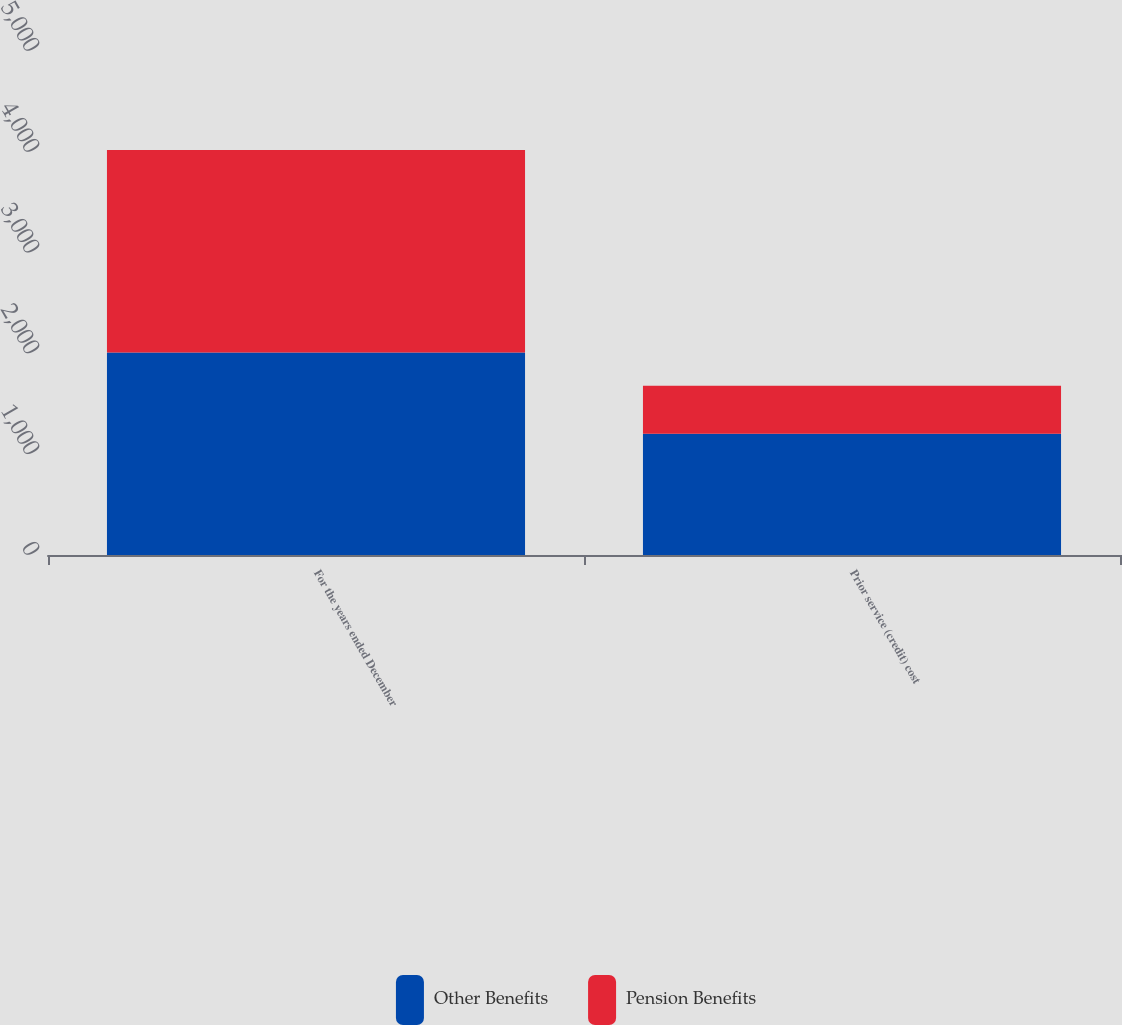Convert chart to OTSL. <chart><loc_0><loc_0><loc_500><loc_500><stacked_bar_chart><ecel><fcel>For the years ended December<fcel>Prior service (credit) cost<nl><fcel>Other Benefits<fcel>2009<fcel>1204<nl><fcel>Pension Benefits<fcel>2009<fcel>474<nl></chart> 